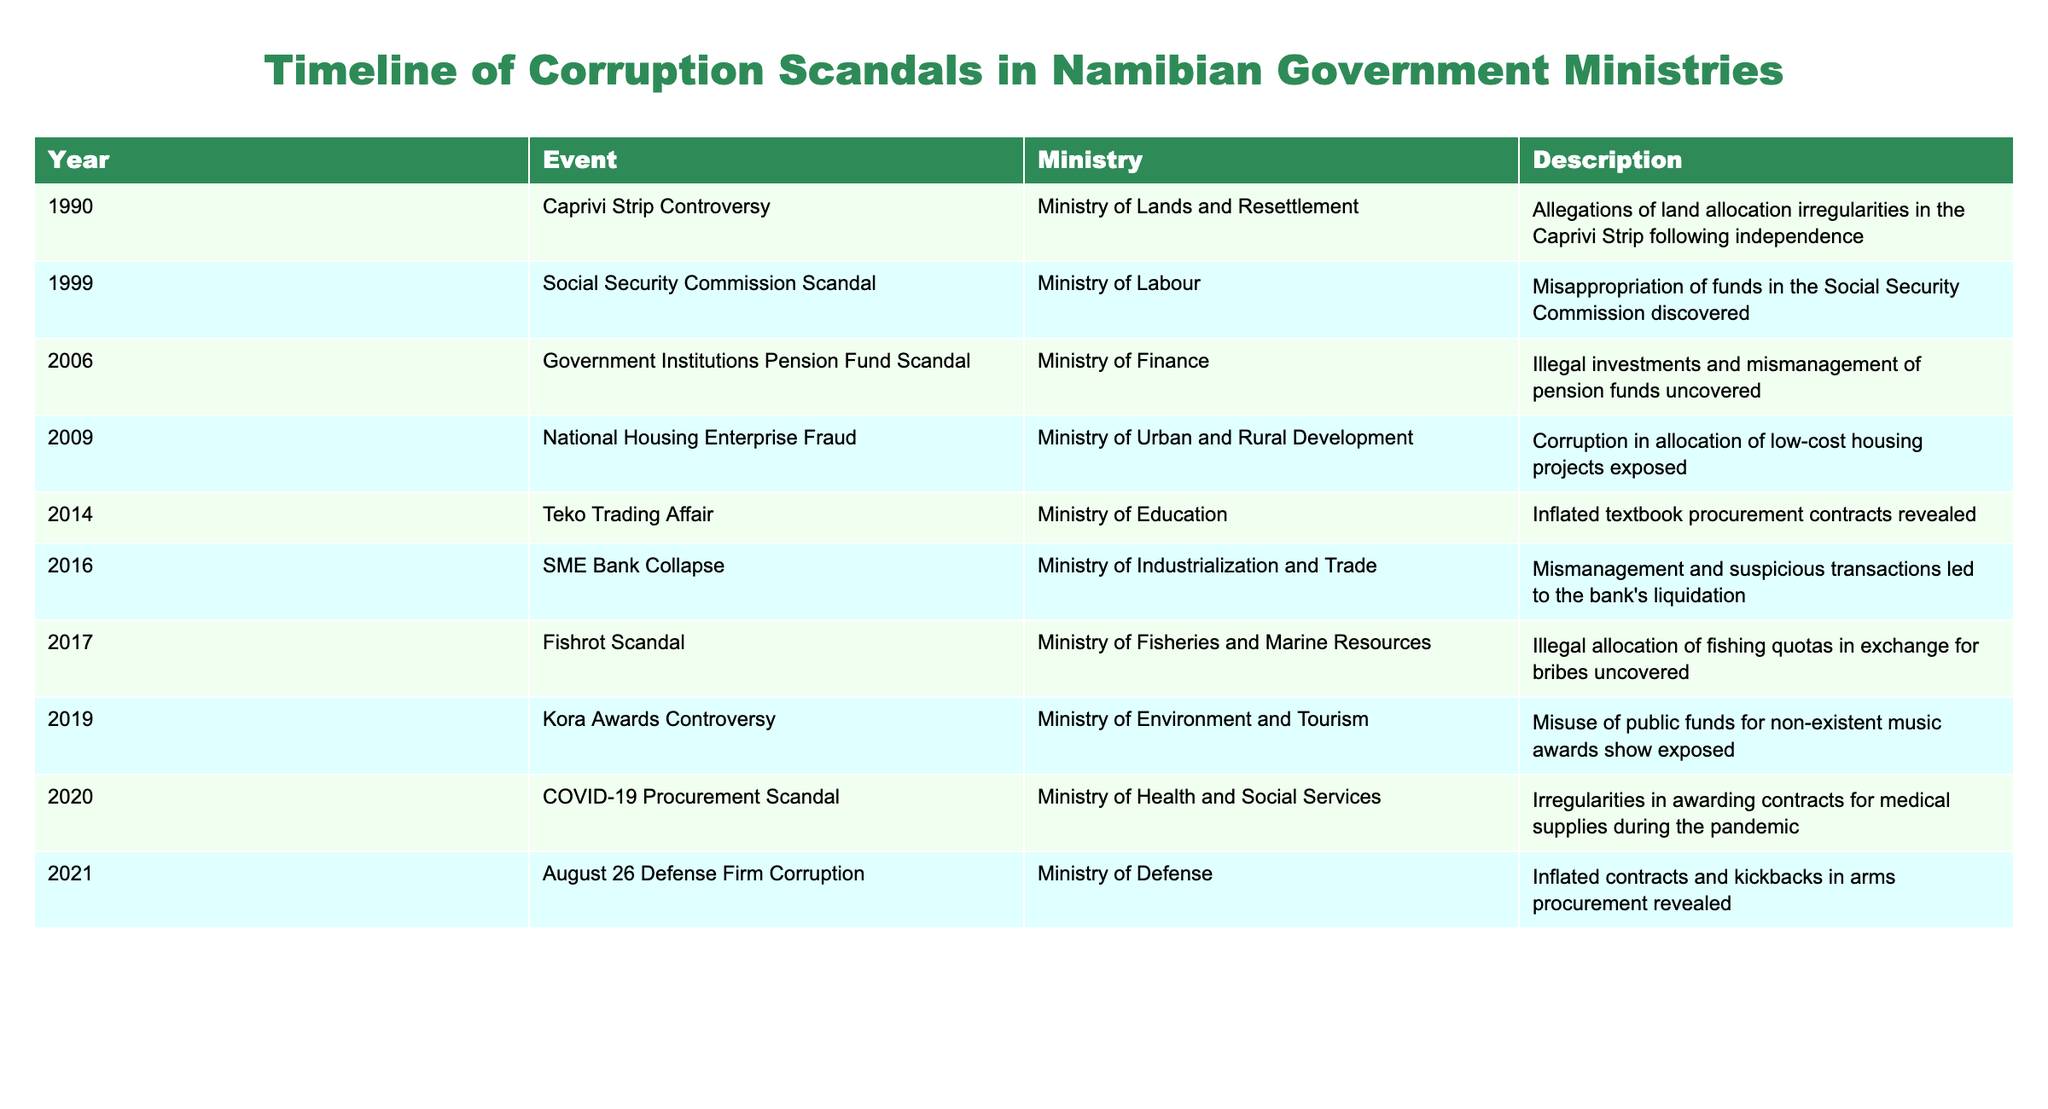What year did the Fishrot Scandal occur? The table indicates that the Fishrot Scandal was reported in the year 2017 under the Ministry of Fisheries and Marine Resources.
Answer: 2017 How many scandals occurred under the Ministry of Education? According to the table, only one scandal, the Teko Trading Affair, is listed under the Ministry of Education for the year 2014.
Answer: 1 What is the difference in years between the first and last events in the timeline? The first event occurred in 1990 and the last event in 2021. The difference is 2021 - 1990 = 31 years.
Answer: 31 Was there any scandal related to the Ministry of Health and Social Services? Yes, the COVID-19 Procurement Scandal in 2020 involved the Ministry of Health and Social Services as per the table.
Answer: Yes How many scandals occurred between 2010 and 2020, inclusive? The table lists the following scandals in this timeframe: National Housing Enterprise Fraud in 2009, Teko Trading Affair in 2014, SME Bank Collapse in 2016, Fishrot Scandal in 2017, Kora Awards Controversy in 2019, and COVID-19 Procurement Scandal in 2020. Counting these events shows that there are five scandals from 2014 to 2020.
Answer: 5 What was the most recent scandal listed in the table? The table shows that the most recent scandal occurred in 2021, specifically the August 26 Defense Firm Corruption under the Ministry of Defense.
Answer: 2021 How many ministries are involved in the listed scandals? By analyzing the table, the involved ministries are: Ministry of Lands and Resettlement, Ministry of Labour, Ministry of Finance, Ministry of Urban and Rural Development, Ministry of Education, Ministry of Industrialization and Trade, Ministry of Fisheries and Marine Resources, Ministry of Environment and Tourism, and Ministry of Health and Social Services, totaling nine distinct ministries.
Answer: 9 Was the Social Security Commission Scandal associated with any allegations of bribery? The description in the table does not mention bribery specifically in connection with the Social Security Commission Scandal, it only indicates misappropriation of funds.
Answer: No Which scandal involved illegal investments? The Government Institutions Pension Fund Scandal from 2006 involved illegal investments and mismanagement of pension funds as noted in the table.
Answer: Government Institutions Pension Fund Scandal 